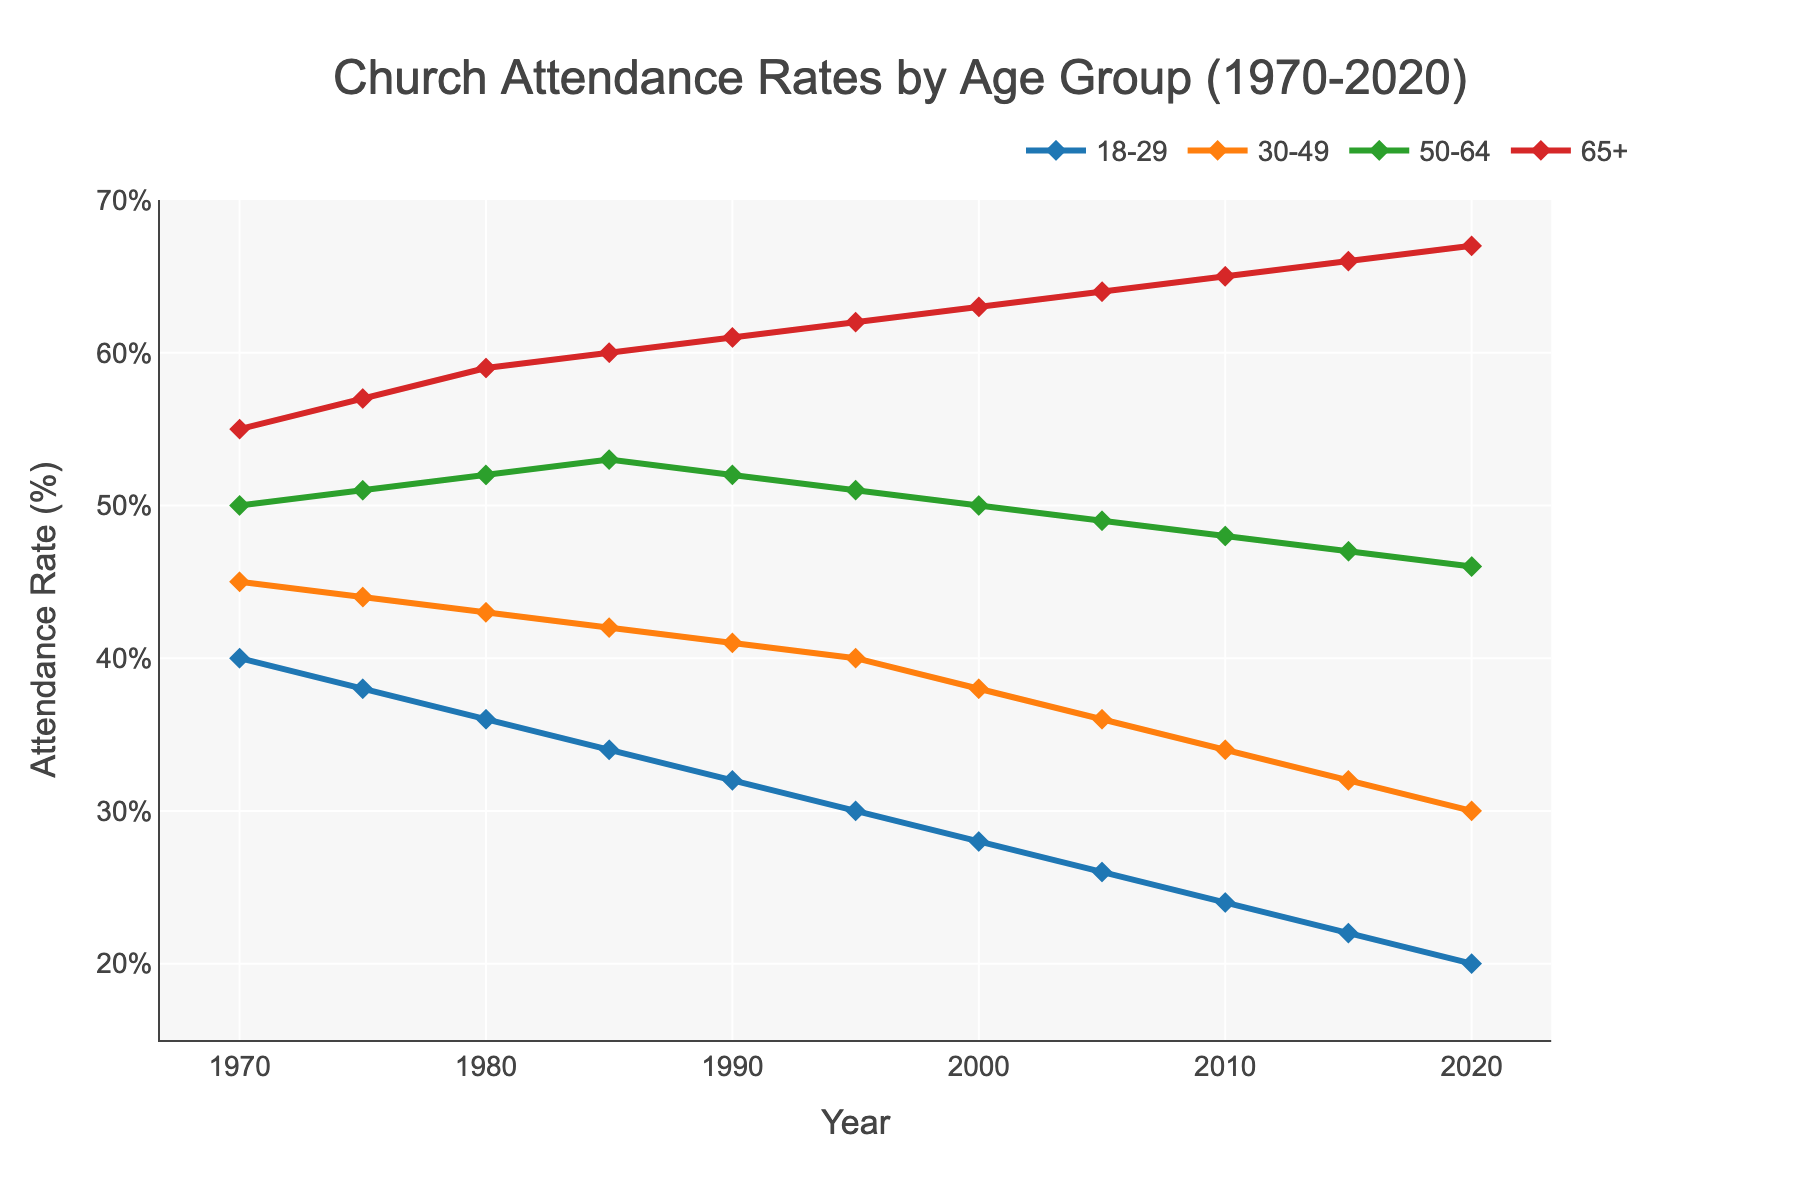What is the average church attendance rate of the 18-29 age group across all years? To find the average, sum all the attendance rates for the 18-29 age group from 1970 to 2020 and then divide by the total number of years (11). The sum is 40 + 38 + 36 + 34 + 32 + 30 + 28 + 26 + 24 + 22 + 20 = 330, so the average is 330/11 = 30%
Answer: 30% Which age group had the highest church attendance rate in 1990? To determine which age group had the highest attendance rate in 1990, compare the values across the age groups for that year: 18-29 (32%), 30-49 (41%), 50-64 (52%), 65+ (61%). The highest rate is 61% in the 65+ age group
Answer: 65+ By how much did the church attendance rate for the 30-49 age group drop from 1970 to 2020? Subtract the 2020 attendance rate of the 30-49 age group (30%) from the 1970 attendance rate (45%). The difference is 45% - 30% = 15%
Answer: 15% Between which consecutive decades did the 50-64 age group experience the greatest decrease in attendance rate? Calculate the change in attendance rate for each decade: between 1970-1980: 50-52 = -2, between 1980-1990: 52-52 = 0, between 1990-2000: 52-50 = -2, between 2000-2010: 50-48 = -2, between 2010-2020: 48-46 = -2. All decreases are -2%, so no specific decade stands out
Answer: All decades same (-2%) What trend can be observed in the church attendance rates for all age groups over the entire 50 years? By observing the individual lines for each age group from 1970 to 2020, it’s clear that all age groups show a consistent decreasing trend in attendance rates, with the steepest declines in the younger age groups and more moderate declines in the older age groups
Answer: Declining trend Which age group consistently maintained the highest church attendance rate between 1970 and 2020? Observing the trends, the 65+ age group consistently maintained the highest attendance rate throughout the 50-year period compared to the other age groups.
Answer: 65+ What is the difference in church attendance rates between the 18-29 and 50-64 age groups in 2015? Subtract the 2015 attendance rate of the 18-29 age group (22%) from the rate of the 50-64 age group (47%). The difference is 47% - 22% = 25%
Answer: 25% What color represents the 30-49 age group in the plot? Observing the plot, the 30-49 age group is represented by the orange line.
Answer: Orange Which age group had the smallest decrease in church attendance rate from 1970 to 2020? Calculate the decrease for each age group: 
18-29: 40 - 20 = 20%,
30-49: 45 - 30 = 15%, 
50-64: 50 - 46 = 4%,
65+: 55 - 67 = -12%.
The 50-64 age group had the smallest decrease.
Answer: 50-64 